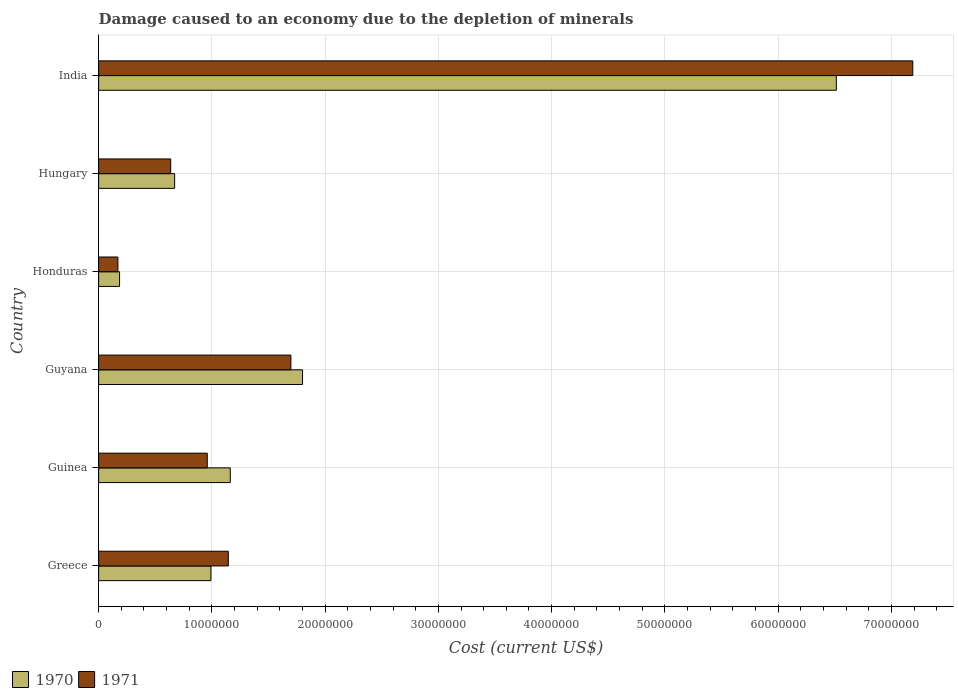How many different coloured bars are there?
Keep it short and to the point. 2. Are the number of bars per tick equal to the number of legend labels?
Your response must be concise. Yes. Are the number of bars on each tick of the Y-axis equal?
Give a very brief answer. Yes. How many bars are there on the 5th tick from the bottom?
Your answer should be compact. 2. What is the cost of damage caused due to the depletion of minerals in 1971 in Guyana?
Make the answer very short. 1.70e+07. Across all countries, what is the maximum cost of damage caused due to the depletion of minerals in 1970?
Your response must be concise. 6.51e+07. Across all countries, what is the minimum cost of damage caused due to the depletion of minerals in 1971?
Give a very brief answer. 1.70e+06. In which country was the cost of damage caused due to the depletion of minerals in 1971 minimum?
Your answer should be very brief. Honduras. What is the total cost of damage caused due to the depletion of minerals in 1970 in the graph?
Provide a succinct answer. 1.13e+08. What is the difference between the cost of damage caused due to the depletion of minerals in 1971 in Greece and that in India?
Your answer should be very brief. -6.04e+07. What is the difference between the cost of damage caused due to the depletion of minerals in 1970 in Greece and the cost of damage caused due to the depletion of minerals in 1971 in Guinea?
Provide a short and direct response. 3.26e+05. What is the average cost of damage caused due to the depletion of minerals in 1970 per country?
Your response must be concise. 1.89e+07. What is the difference between the cost of damage caused due to the depletion of minerals in 1971 and cost of damage caused due to the depletion of minerals in 1970 in Hungary?
Your answer should be very brief. -3.48e+05. In how many countries, is the cost of damage caused due to the depletion of minerals in 1971 greater than 4000000 US$?
Keep it short and to the point. 5. What is the ratio of the cost of damage caused due to the depletion of minerals in 1971 in Guinea to that in Hungary?
Provide a succinct answer. 1.51. Is the difference between the cost of damage caused due to the depletion of minerals in 1971 in Greece and Hungary greater than the difference between the cost of damage caused due to the depletion of minerals in 1970 in Greece and Hungary?
Provide a short and direct response. Yes. What is the difference between the highest and the second highest cost of damage caused due to the depletion of minerals in 1971?
Offer a very short reply. 5.49e+07. What is the difference between the highest and the lowest cost of damage caused due to the depletion of minerals in 1971?
Make the answer very short. 7.02e+07. In how many countries, is the cost of damage caused due to the depletion of minerals in 1971 greater than the average cost of damage caused due to the depletion of minerals in 1971 taken over all countries?
Ensure brevity in your answer.  1. What does the 2nd bar from the top in Guyana represents?
Make the answer very short. 1970. Are all the bars in the graph horizontal?
Provide a succinct answer. Yes. What is the difference between two consecutive major ticks on the X-axis?
Offer a very short reply. 1.00e+07. Does the graph contain grids?
Offer a terse response. Yes. How many legend labels are there?
Offer a very short reply. 2. How are the legend labels stacked?
Keep it short and to the point. Horizontal. What is the title of the graph?
Your answer should be very brief. Damage caused to an economy due to the depletion of minerals. Does "1992" appear as one of the legend labels in the graph?
Provide a short and direct response. No. What is the label or title of the X-axis?
Keep it short and to the point. Cost (current US$). What is the label or title of the Y-axis?
Offer a terse response. Country. What is the Cost (current US$) in 1970 in Greece?
Keep it short and to the point. 9.92e+06. What is the Cost (current US$) in 1971 in Greece?
Keep it short and to the point. 1.15e+07. What is the Cost (current US$) of 1970 in Guinea?
Provide a short and direct response. 1.16e+07. What is the Cost (current US$) in 1971 in Guinea?
Provide a succinct answer. 9.59e+06. What is the Cost (current US$) of 1970 in Guyana?
Make the answer very short. 1.80e+07. What is the Cost (current US$) of 1971 in Guyana?
Make the answer very short. 1.70e+07. What is the Cost (current US$) in 1970 in Honduras?
Offer a very short reply. 1.85e+06. What is the Cost (current US$) in 1971 in Honduras?
Offer a terse response. 1.70e+06. What is the Cost (current US$) in 1970 in Hungary?
Your answer should be very brief. 6.71e+06. What is the Cost (current US$) of 1971 in Hungary?
Provide a short and direct response. 6.36e+06. What is the Cost (current US$) in 1970 in India?
Your answer should be compact. 6.51e+07. What is the Cost (current US$) of 1971 in India?
Provide a short and direct response. 7.19e+07. Across all countries, what is the maximum Cost (current US$) in 1970?
Make the answer very short. 6.51e+07. Across all countries, what is the maximum Cost (current US$) of 1971?
Provide a short and direct response. 7.19e+07. Across all countries, what is the minimum Cost (current US$) of 1970?
Provide a succinct answer. 1.85e+06. Across all countries, what is the minimum Cost (current US$) of 1971?
Make the answer very short. 1.70e+06. What is the total Cost (current US$) of 1970 in the graph?
Your answer should be compact. 1.13e+08. What is the total Cost (current US$) of 1971 in the graph?
Make the answer very short. 1.18e+08. What is the difference between the Cost (current US$) in 1970 in Greece and that in Guinea?
Provide a short and direct response. -1.71e+06. What is the difference between the Cost (current US$) in 1971 in Greece and that in Guinea?
Provide a short and direct response. 1.86e+06. What is the difference between the Cost (current US$) in 1970 in Greece and that in Guyana?
Ensure brevity in your answer.  -8.09e+06. What is the difference between the Cost (current US$) in 1971 in Greece and that in Guyana?
Make the answer very short. -5.52e+06. What is the difference between the Cost (current US$) of 1970 in Greece and that in Honduras?
Your answer should be very brief. 8.07e+06. What is the difference between the Cost (current US$) in 1971 in Greece and that in Honduras?
Keep it short and to the point. 9.75e+06. What is the difference between the Cost (current US$) in 1970 in Greece and that in Hungary?
Keep it short and to the point. 3.21e+06. What is the difference between the Cost (current US$) of 1971 in Greece and that in Hungary?
Provide a succinct answer. 5.09e+06. What is the difference between the Cost (current US$) in 1970 in Greece and that in India?
Provide a short and direct response. -5.52e+07. What is the difference between the Cost (current US$) of 1971 in Greece and that in India?
Make the answer very short. -6.04e+07. What is the difference between the Cost (current US$) of 1970 in Guinea and that in Guyana?
Give a very brief answer. -6.38e+06. What is the difference between the Cost (current US$) of 1971 in Guinea and that in Guyana?
Keep it short and to the point. -7.38e+06. What is the difference between the Cost (current US$) in 1970 in Guinea and that in Honduras?
Your answer should be compact. 9.78e+06. What is the difference between the Cost (current US$) in 1971 in Guinea and that in Honduras?
Give a very brief answer. 7.89e+06. What is the difference between the Cost (current US$) of 1970 in Guinea and that in Hungary?
Ensure brevity in your answer.  4.91e+06. What is the difference between the Cost (current US$) in 1971 in Guinea and that in Hungary?
Provide a short and direct response. 3.23e+06. What is the difference between the Cost (current US$) of 1970 in Guinea and that in India?
Your response must be concise. -5.35e+07. What is the difference between the Cost (current US$) of 1971 in Guinea and that in India?
Keep it short and to the point. -6.23e+07. What is the difference between the Cost (current US$) in 1970 in Guyana and that in Honduras?
Offer a terse response. 1.62e+07. What is the difference between the Cost (current US$) in 1971 in Guyana and that in Honduras?
Offer a very short reply. 1.53e+07. What is the difference between the Cost (current US$) in 1970 in Guyana and that in Hungary?
Offer a very short reply. 1.13e+07. What is the difference between the Cost (current US$) in 1971 in Guyana and that in Hungary?
Make the answer very short. 1.06e+07. What is the difference between the Cost (current US$) in 1970 in Guyana and that in India?
Offer a very short reply. -4.71e+07. What is the difference between the Cost (current US$) in 1971 in Guyana and that in India?
Offer a very short reply. -5.49e+07. What is the difference between the Cost (current US$) of 1970 in Honduras and that in Hungary?
Offer a very short reply. -4.86e+06. What is the difference between the Cost (current US$) of 1971 in Honduras and that in Hungary?
Your answer should be very brief. -4.66e+06. What is the difference between the Cost (current US$) of 1970 in Honduras and that in India?
Give a very brief answer. -6.33e+07. What is the difference between the Cost (current US$) in 1971 in Honduras and that in India?
Provide a succinct answer. -7.02e+07. What is the difference between the Cost (current US$) of 1970 in Hungary and that in India?
Keep it short and to the point. -5.84e+07. What is the difference between the Cost (current US$) in 1971 in Hungary and that in India?
Give a very brief answer. -6.55e+07. What is the difference between the Cost (current US$) in 1970 in Greece and the Cost (current US$) in 1971 in Guinea?
Offer a terse response. 3.26e+05. What is the difference between the Cost (current US$) of 1970 in Greece and the Cost (current US$) of 1971 in Guyana?
Your answer should be compact. -7.06e+06. What is the difference between the Cost (current US$) in 1970 in Greece and the Cost (current US$) in 1971 in Honduras?
Give a very brief answer. 8.21e+06. What is the difference between the Cost (current US$) in 1970 in Greece and the Cost (current US$) in 1971 in Hungary?
Ensure brevity in your answer.  3.55e+06. What is the difference between the Cost (current US$) of 1970 in Greece and the Cost (current US$) of 1971 in India?
Give a very brief answer. -6.20e+07. What is the difference between the Cost (current US$) of 1970 in Guinea and the Cost (current US$) of 1971 in Guyana?
Give a very brief answer. -5.35e+06. What is the difference between the Cost (current US$) in 1970 in Guinea and the Cost (current US$) in 1971 in Honduras?
Provide a short and direct response. 9.92e+06. What is the difference between the Cost (current US$) in 1970 in Guinea and the Cost (current US$) in 1971 in Hungary?
Offer a terse response. 5.26e+06. What is the difference between the Cost (current US$) in 1970 in Guinea and the Cost (current US$) in 1971 in India?
Offer a terse response. -6.03e+07. What is the difference between the Cost (current US$) in 1970 in Guyana and the Cost (current US$) in 1971 in Honduras?
Ensure brevity in your answer.  1.63e+07. What is the difference between the Cost (current US$) of 1970 in Guyana and the Cost (current US$) of 1971 in Hungary?
Give a very brief answer. 1.16e+07. What is the difference between the Cost (current US$) in 1970 in Guyana and the Cost (current US$) in 1971 in India?
Your answer should be very brief. -5.39e+07. What is the difference between the Cost (current US$) in 1970 in Honduras and the Cost (current US$) in 1971 in Hungary?
Offer a terse response. -4.51e+06. What is the difference between the Cost (current US$) in 1970 in Honduras and the Cost (current US$) in 1971 in India?
Make the answer very short. -7.00e+07. What is the difference between the Cost (current US$) in 1970 in Hungary and the Cost (current US$) in 1971 in India?
Provide a succinct answer. -6.52e+07. What is the average Cost (current US$) of 1970 per country?
Offer a terse response. 1.89e+07. What is the average Cost (current US$) in 1971 per country?
Offer a terse response. 1.97e+07. What is the difference between the Cost (current US$) in 1970 and Cost (current US$) in 1971 in Greece?
Give a very brief answer. -1.53e+06. What is the difference between the Cost (current US$) in 1970 and Cost (current US$) in 1971 in Guinea?
Provide a short and direct response. 2.03e+06. What is the difference between the Cost (current US$) of 1970 and Cost (current US$) of 1971 in Guyana?
Make the answer very short. 1.03e+06. What is the difference between the Cost (current US$) in 1970 and Cost (current US$) in 1971 in Honduras?
Provide a succinct answer. 1.47e+05. What is the difference between the Cost (current US$) of 1970 and Cost (current US$) of 1971 in Hungary?
Your response must be concise. 3.48e+05. What is the difference between the Cost (current US$) of 1970 and Cost (current US$) of 1971 in India?
Provide a short and direct response. -6.75e+06. What is the ratio of the Cost (current US$) of 1970 in Greece to that in Guinea?
Provide a short and direct response. 0.85. What is the ratio of the Cost (current US$) of 1971 in Greece to that in Guinea?
Make the answer very short. 1.19. What is the ratio of the Cost (current US$) of 1970 in Greece to that in Guyana?
Your answer should be very brief. 0.55. What is the ratio of the Cost (current US$) in 1971 in Greece to that in Guyana?
Provide a short and direct response. 0.67. What is the ratio of the Cost (current US$) in 1970 in Greece to that in Honduras?
Your response must be concise. 5.36. What is the ratio of the Cost (current US$) in 1971 in Greece to that in Honduras?
Provide a succinct answer. 6.73. What is the ratio of the Cost (current US$) in 1970 in Greece to that in Hungary?
Your answer should be very brief. 1.48. What is the ratio of the Cost (current US$) of 1971 in Greece to that in Hungary?
Your answer should be compact. 1.8. What is the ratio of the Cost (current US$) in 1970 in Greece to that in India?
Give a very brief answer. 0.15. What is the ratio of the Cost (current US$) in 1971 in Greece to that in India?
Keep it short and to the point. 0.16. What is the ratio of the Cost (current US$) of 1970 in Guinea to that in Guyana?
Make the answer very short. 0.65. What is the ratio of the Cost (current US$) of 1971 in Guinea to that in Guyana?
Offer a terse response. 0.56. What is the ratio of the Cost (current US$) of 1970 in Guinea to that in Honduras?
Keep it short and to the point. 6.29. What is the ratio of the Cost (current US$) in 1971 in Guinea to that in Honduras?
Give a very brief answer. 5.63. What is the ratio of the Cost (current US$) of 1970 in Guinea to that in Hungary?
Your response must be concise. 1.73. What is the ratio of the Cost (current US$) of 1971 in Guinea to that in Hungary?
Offer a very short reply. 1.51. What is the ratio of the Cost (current US$) of 1970 in Guinea to that in India?
Offer a very short reply. 0.18. What is the ratio of the Cost (current US$) of 1971 in Guinea to that in India?
Your response must be concise. 0.13. What is the ratio of the Cost (current US$) of 1970 in Guyana to that in Honduras?
Your answer should be very brief. 9.74. What is the ratio of the Cost (current US$) of 1971 in Guyana to that in Honduras?
Provide a short and direct response. 9.97. What is the ratio of the Cost (current US$) in 1970 in Guyana to that in Hungary?
Keep it short and to the point. 2.68. What is the ratio of the Cost (current US$) of 1971 in Guyana to that in Hungary?
Ensure brevity in your answer.  2.67. What is the ratio of the Cost (current US$) of 1970 in Guyana to that in India?
Ensure brevity in your answer.  0.28. What is the ratio of the Cost (current US$) in 1971 in Guyana to that in India?
Your answer should be very brief. 0.24. What is the ratio of the Cost (current US$) in 1970 in Honduras to that in Hungary?
Keep it short and to the point. 0.28. What is the ratio of the Cost (current US$) in 1971 in Honduras to that in Hungary?
Offer a terse response. 0.27. What is the ratio of the Cost (current US$) in 1970 in Honduras to that in India?
Offer a terse response. 0.03. What is the ratio of the Cost (current US$) of 1971 in Honduras to that in India?
Keep it short and to the point. 0.02. What is the ratio of the Cost (current US$) of 1970 in Hungary to that in India?
Offer a very short reply. 0.1. What is the ratio of the Cost (current US$) of 1971 in Hungary to that in India?
Your answer should be compact. 0.09. What is the difference between the highest and the second highest Cost (current US$) of 1970?
Provide a succinct answer. 4.71e+07. What is the difference between the highest and the second highest Cost (current US$) of 1971?
Give a very brief answer. 5.49e+07. What is the difference between the highest and the lowest Cost (current US$) in 1970?
Make the answer very short. 6.33e+07. What is the difference between the highest and the lowest Cost (current US$) of 1971?
Ensure brevity in your answer.  7.02e+07. 